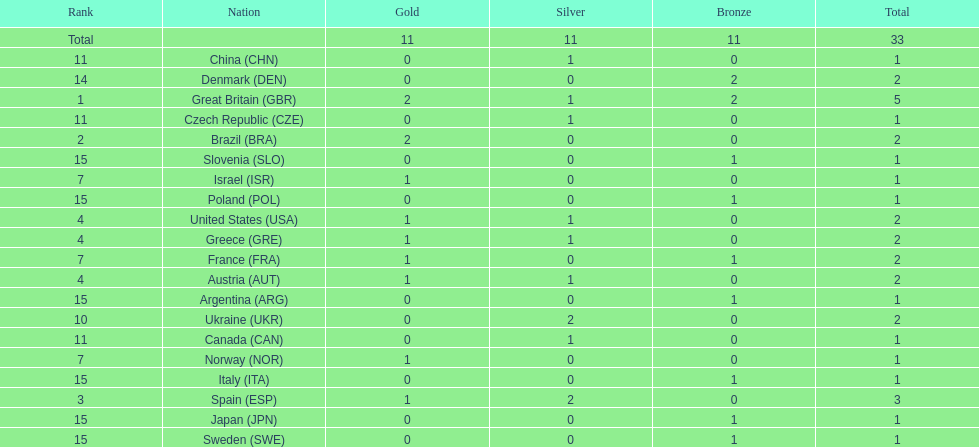Who won more gold medals than spain? Great Britain (GBR), Brazil (BRA). 